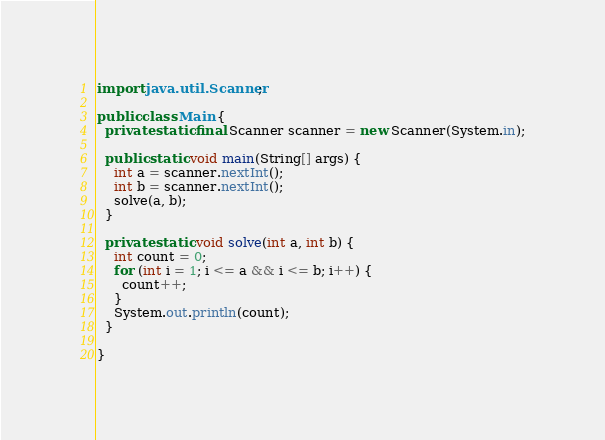Convert code to text. <code><loc_0><loc_0><loc_500><loc_500><_Java_>import java.util.Scanner;

public class Main {
  private static final Scanner scanner = new Scanner(System.in);

  public static void main(String[] args) {
    int a = scanner.nextInt();
    int b = scanner.nextInt();
    solve(a, b);
  }

  private static void solve(int a, int b) {
    int count = 0;
    for (int i = 1; i <= a && i <= b; i++) {
      count++;
    }
    System.out.println(count);
  }

}</code> 